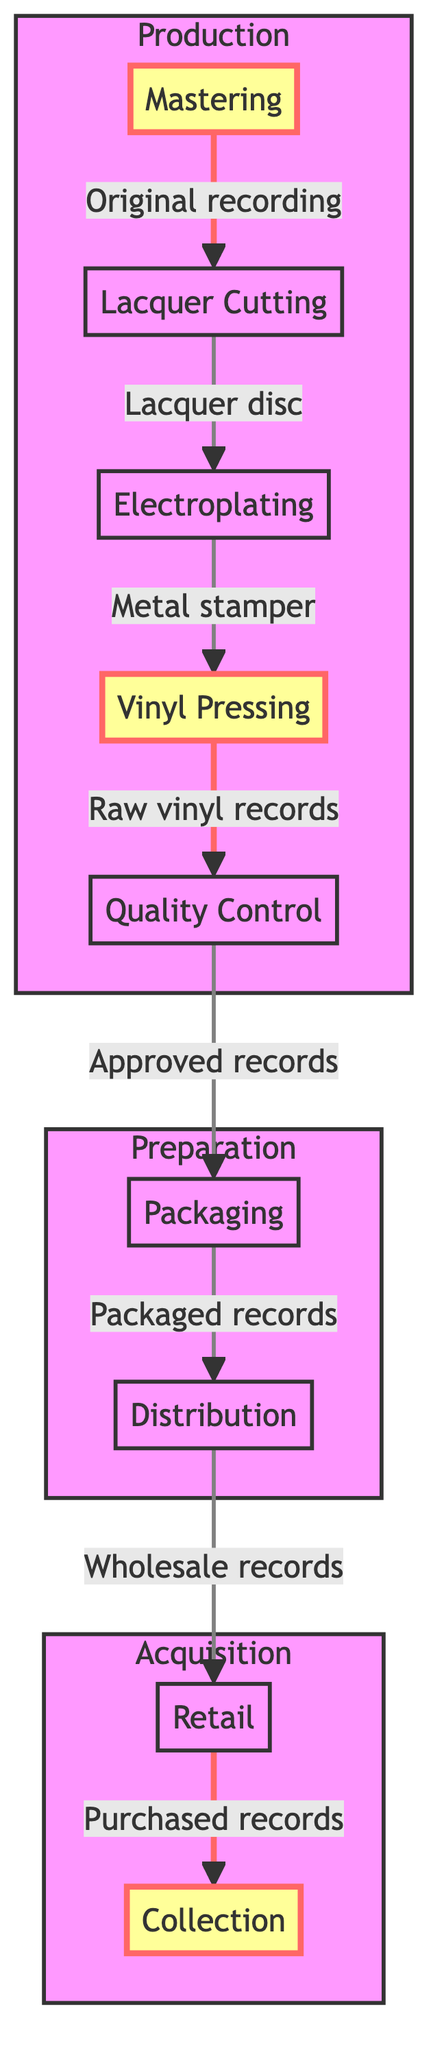What is the first stage in the journey of a vinyl record? The diagram indicates that the first stage in the journey is "Mastering," as it is the initial step that leads to the subsequent stages.
Answer: Mastering How many main stages are there in the production section? By counting the nodes that fall under the "Production" subgraph (Mastering, Lacquer Cutting, Electroplating, Vinyl Pressing, Quality Control), there are five stages.
Answer: Five What follows after the "Vinyl Pressing" stage? Based on the flow of the diagram, after "Vinyl Pressing," the next stage is "Quality Control," which is directly linked to it.
Answer: Quality Control Which stage is directly connected to “Packaging”? The diagram shows that "Packaging" follows "Quality Control," meaning that "Quality Control" is directly connected to it.
Answer: Quality Control How many stages are there before the records reach "Retail"? From the beginning at "Mastering" to "Retail," there are seven stages (Mastering, Lacquer Cutting, Electroplating, Vinyl Pressing, Quality Control, Packaging, Distribution). This requires counting each stage in the Production and Preparation subgraphs leading up to Retail.
Answer: Seven Which step involves the creation of a metal stamper? The diagram identifies "Electroplating" as the step where the lacquer disc is turned into a metal stamper. This is confirmed by the directed relationship from "Lacquer Cutting" to "Electroplating."
Answer: Electroplating Which subgraph does the “Collection” fall under? The “Collection” is included in the "Acquisition" subgraph, which encompasses all stages that relate to acquiring the vinyl records.
Answer: Acquisition What is packaged together with vinyl records during the "Packaging" stage? The description for "Packaging" states that records are packaged with covers, inner sleeves, and booklets based on the album artwork. This indicates the various components included during this stage.
Answer: Covers, inner sleeves, booklets What is the final stage in the vinyl production journey? According to the flow of the diagram, the final stage is "Collection," where records are added to a collector’s archive. This is the terminal node of the flow.
Answer: Collection 